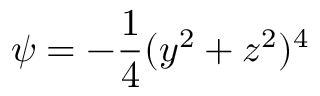<formula> <loc_0><loc_0><loc_500><loc_500>\psi = - \frac { 1 } { 4 } ( y ^ { 2 } + z ^ { 2 } ) ^ { 4 }</formula> 